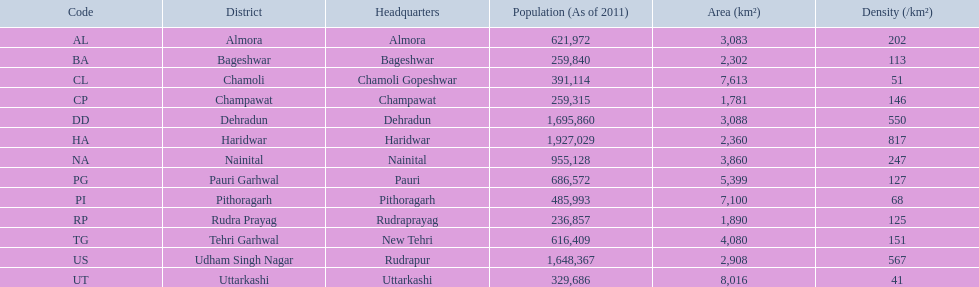How many districts are listed in total? 13. 